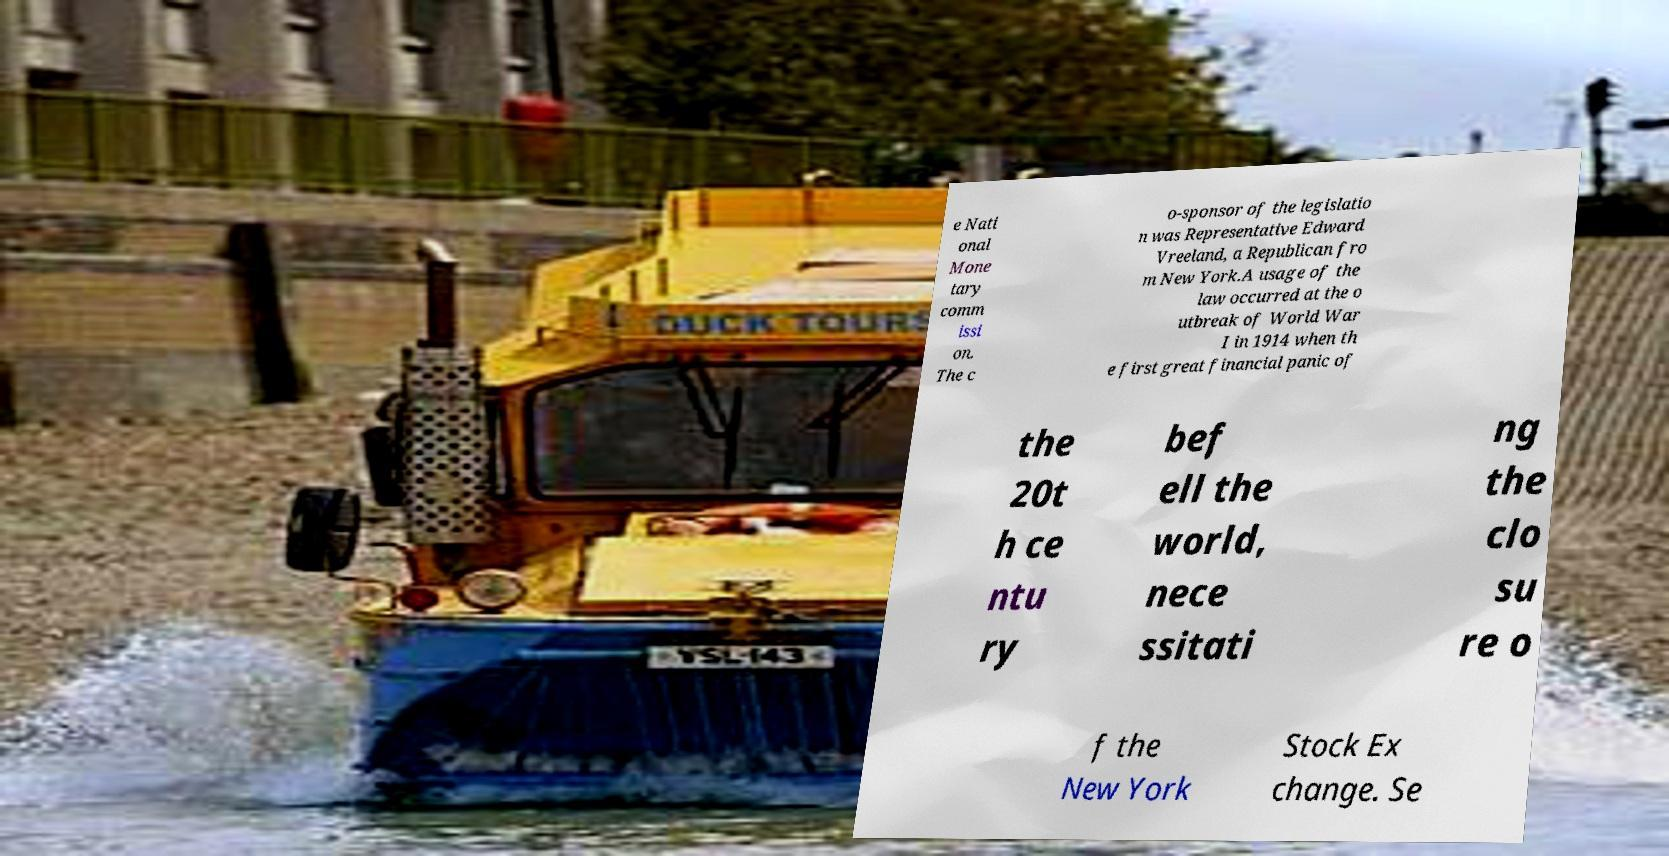Can you read and provide the text displayed in the image?This photo seems to have some interesting text. Can you extract and type it out for me? e Nati onal Mone tary comm issi on. The c o-sponsor of the legislatio n was Representative Edward Vreeland, a Republican fro m New York.A usage of the law occurred at the o utbreak of World War I in 1914 when th e first great financial panic of the 20t h ce ntu ry bef ell the world, nece ssitati ng the clo su re o f the New York Stock Ex change. Se 